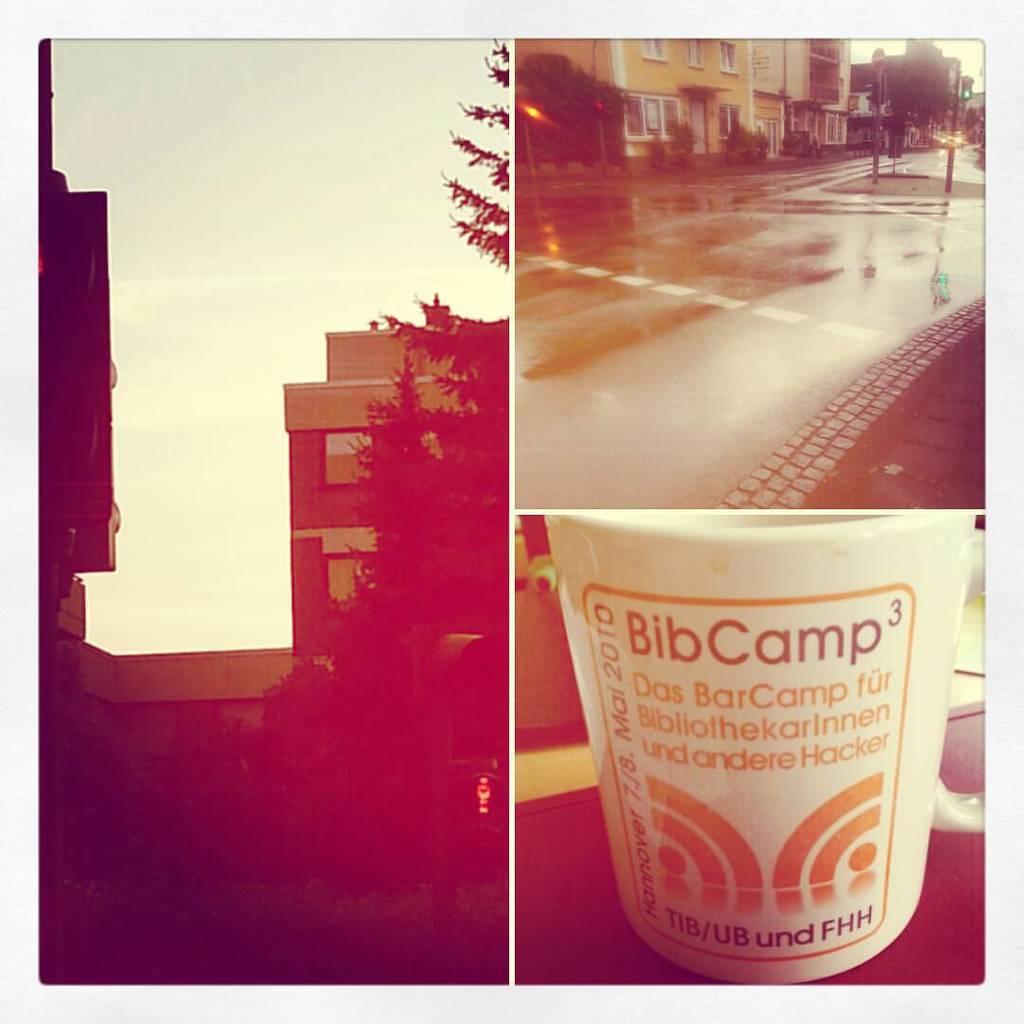What camp is the mug from?
Offer a terse response. Bibcamp. What date is visible on the cup?
Provide a succinct answer. 2010. 